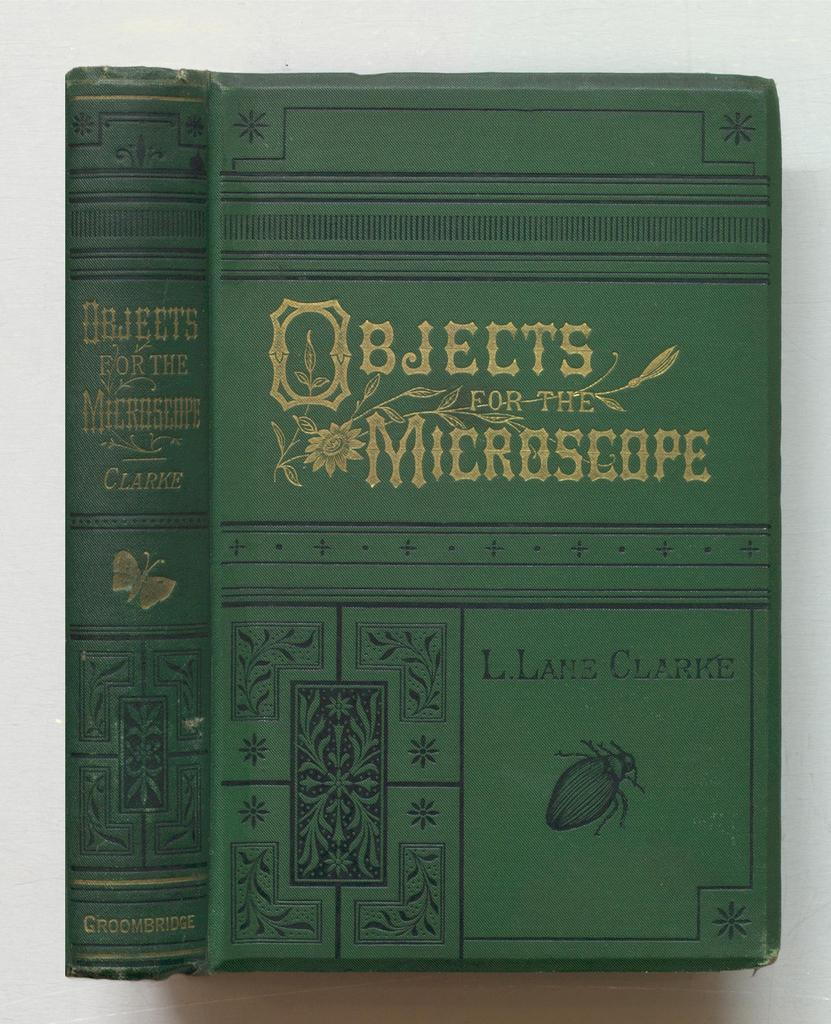<image>
Create a compact narrative representing the image presented. An old looking booked called Objects for the Microscope. 